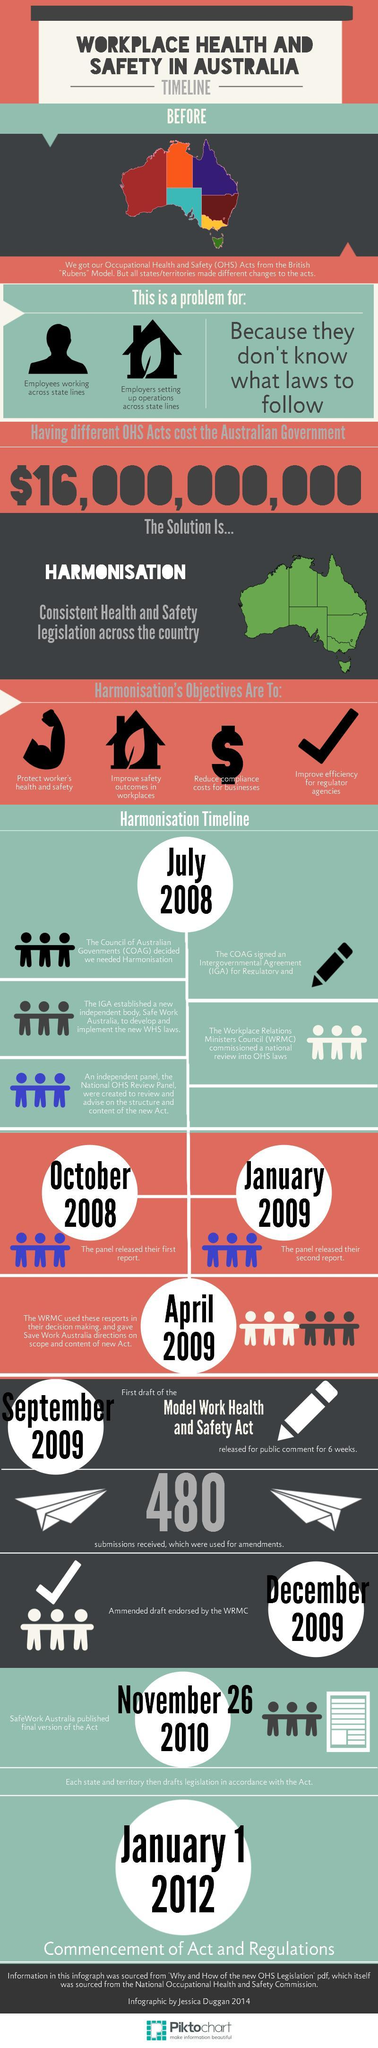When was the first report of the panel released
Answer the question with a short phrase. October 2008 After how many years of the second report by the panel, was the commencement of the Acts and regulations 3 How many objectives are there for harmonisation 4 After how many months of the first report was the second report released by the panel 3 What does the $ symbol indicate in harmonisation objective reduce compliance costs for businesses What does the tick sign in the harmonisation objective indicate Improve efficiency for regulator agencies 